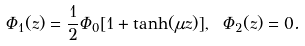Convert formula to latex. <formula><loc_0><loc_0><loc_500><loc_500>\Phi _ { 1 } ( z ) = \frac { 1 } { 2 } \Phi _ { 0 } [ 1 + \tanh ( \mu z ) ] , \ \Phi _ { 2 } ( z ) = 0 .</formula> 